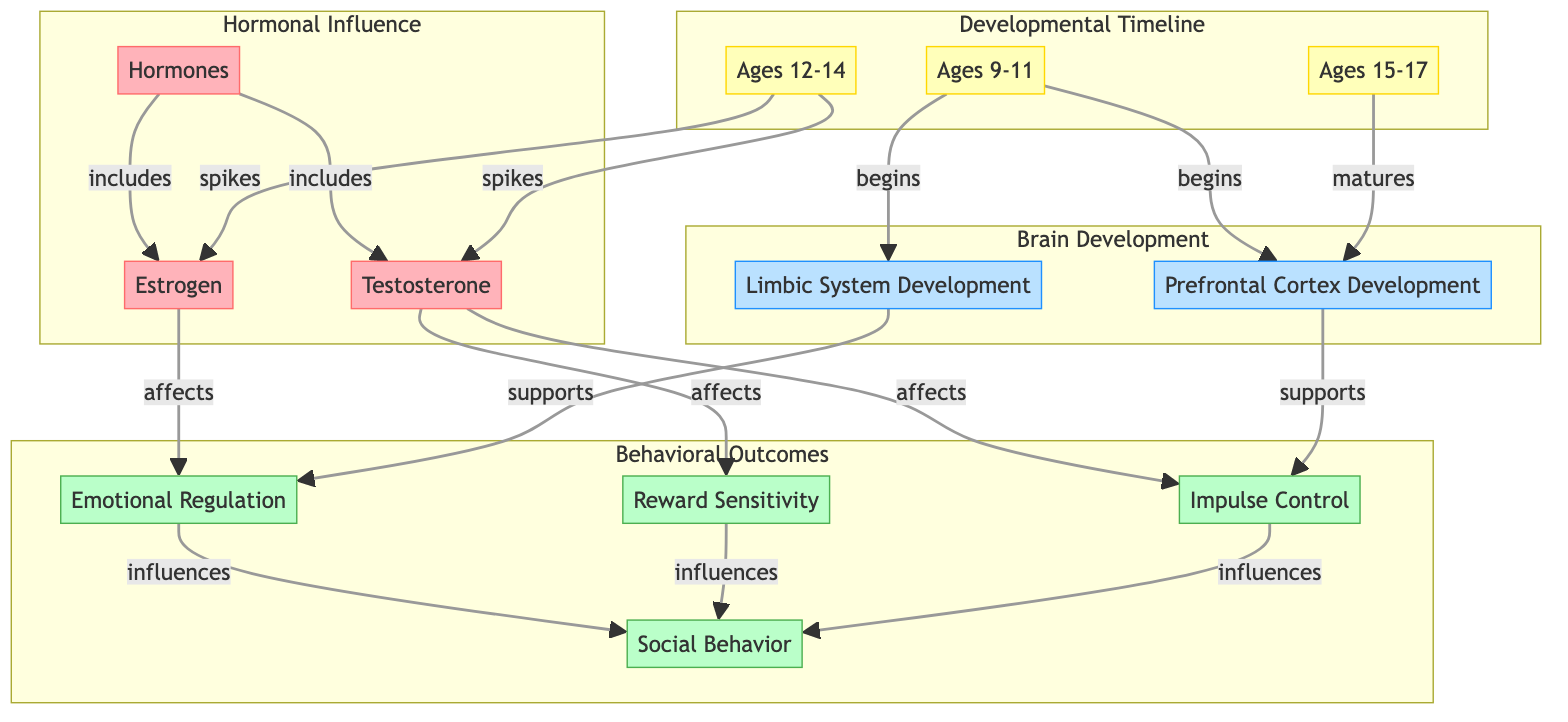What are the two hormones depicted in the diagram? The diagram explicitly lists two hormones: testosterone and estrogen. They are both categorized under the "Hormonal Influence" section.
Answer: testosterone and estrogen At what age range does limbic system development begin? The diagram shows that limbic system development begins in the age range specified as 9-11 years. This is indicated by the arrow linking timeline 9-11 to limbic system development.
Answer: Ages 9-11 Which hormone spikes between ages 12-14? The diagram indicates that both testosterone and estrogen spike during the ages 12-14, as shown by their direct connections to the timeline labeled 12-14.
Answer: testosterone and estrogen How does emotional regulation influence social behavior? The diagram illustrates that emotional regulation has a direct influence on social behavior. This connection is represented by an arrow pointing from emotional regulation to social behavior.
Answer: influences What developmental milestone matures between ages 15-17? According to the diagram, prefrontal cortex development matures during the age range of 15-17 years, which is indicated by the labeling of the timeline 15-17 with an arrow pointing towards prefrontal cortex development.
Answer: prefrontal cortex development Which aspect of social behavior is affected by testosterone? The diagram shows that testosterone affects both impulse control and reward sensitivity, which are components of social behavior. The connections from testosterone lead to these behavioral aspects.
Answer: impulse control and reward sensitivity What primarily supports emotional regulation development? The diagram illustrates that limbic system development primarily supports emotional regulation, as indicated by the arrow linking these two nodes.
Answer: limbic system development How many distinct behavioral outcomes are featured in the diagram? The diagram lists four distinct behavioral outcomes: social behavior, impulse control, reward sensitivity, and emotional regulation. Each outcome is represented as a separate node under the "Behavioral Outcomes" section, resulting in a total of four.
Answer: four 